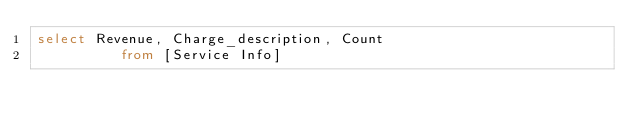Convert code to text. <code><loc_0><loc_0><loc_500><loc_500><_SQL_>select Revenue, Charge_description, Count
          from [Service Info]
</code> 